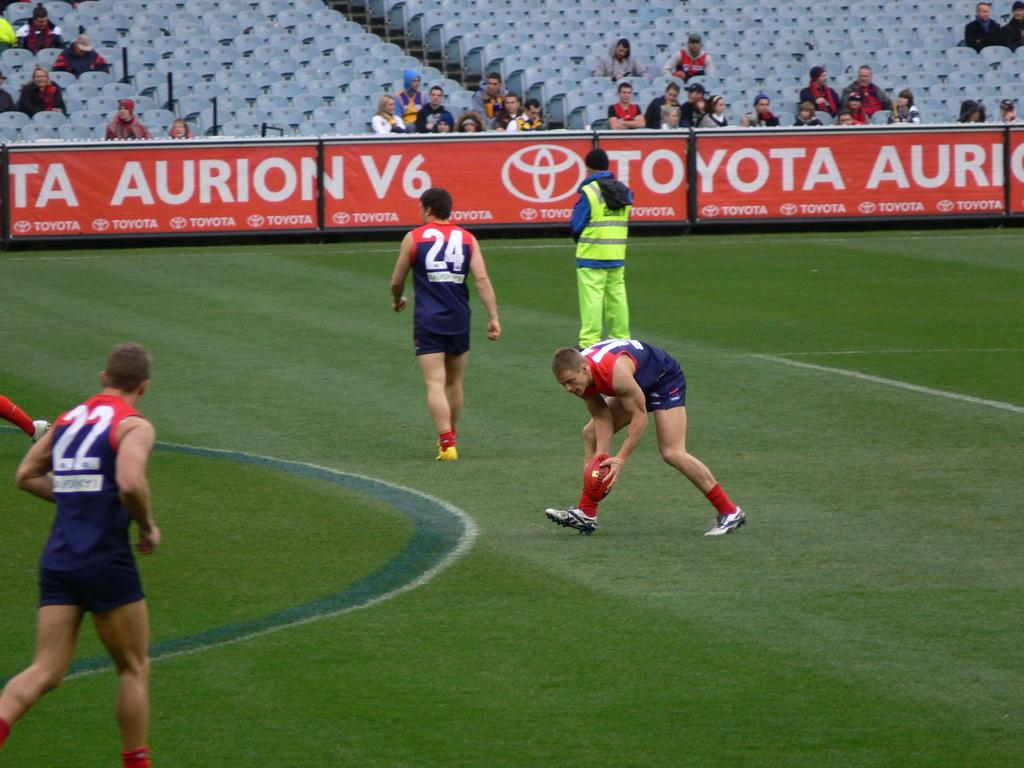<image>
Give a short and clear explanation of the subsequent image. Player number 24 walks on the field towards a Toyota ad 